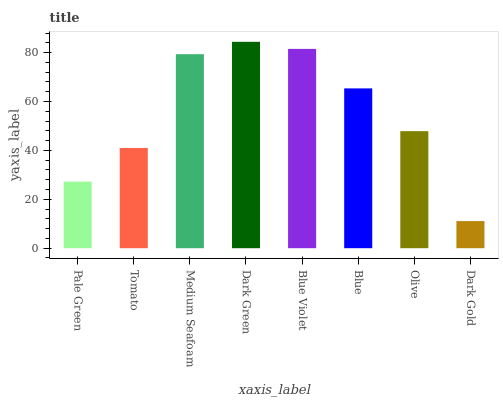Is Dark Gold the minimum?
Answer yes or no. Yes. Is Dark Green the maximum?
Answer yes or no. Yes. Is Tomato the minimum?
Answer yes or no. No. Is Tomato the maximum?
Answer yes or no. No. Is Tomato greater than Pale Green?
Answer yes or no. Yes. Is Pale Green less than Tomato?
Answer yes or no. Yes. Is Pale Green greater than Tomato?
Answer yes or no. No. Is Tomato less than Pale Green?
Answer yes or no. No. Is Blue the high median?
Answer yes or no. Yes. Is Olive the low median?
Answer yes or no. Yes. Is Olive the high median?
Answer yes or no. No. Is Blue the low median?
Answer yes or no. No. 